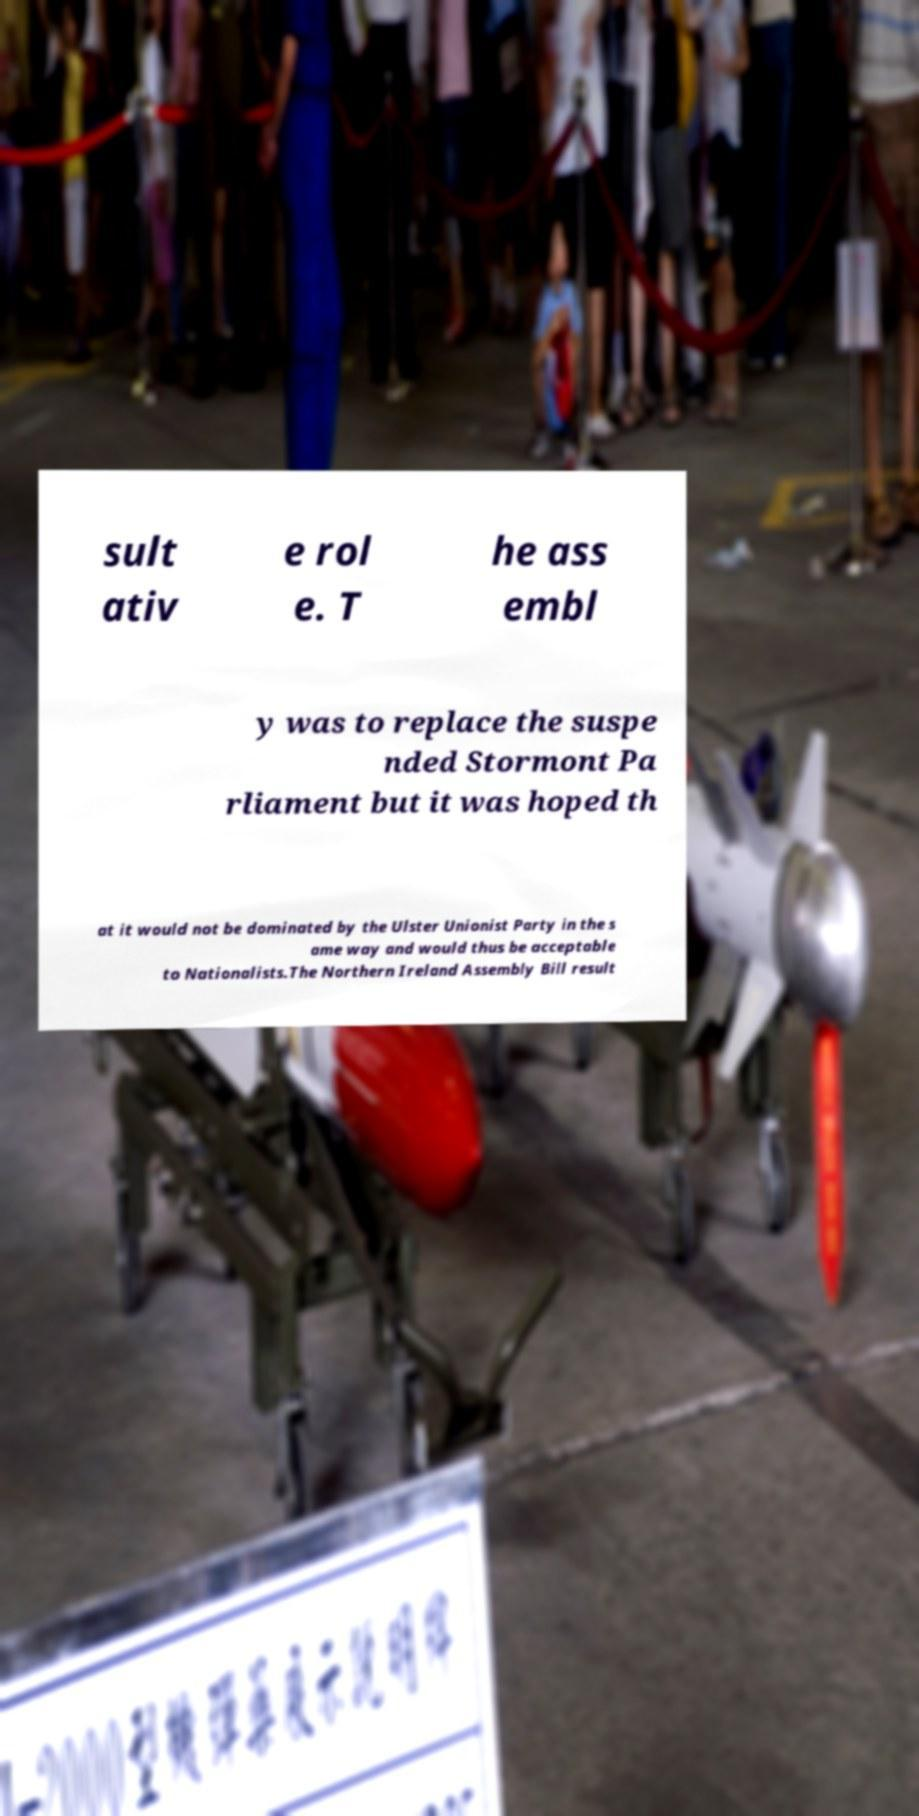Could you assist in decoding the text presented in this image and type it out clearly? sult ativ e rol e. T he ass embl y was to replace the suspe nded Stormont Pa rliament but it was hoped th at it would not be dominated by the Ulster Unionist Party in the s ame way and would thus be acceptable to Nationalists.The Northern Ireland Assembly Bill result 